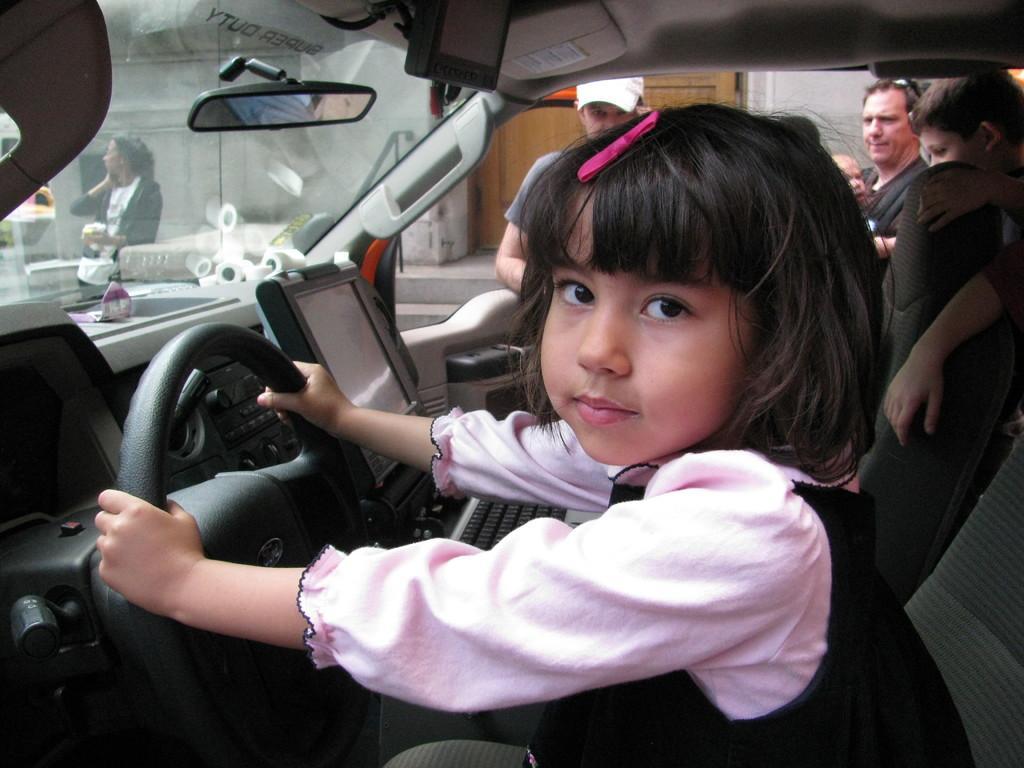How would you summarize this image in a sentence or two? In this image we can see a child sitting in the car and holding steering. In the background we can see people standing. 